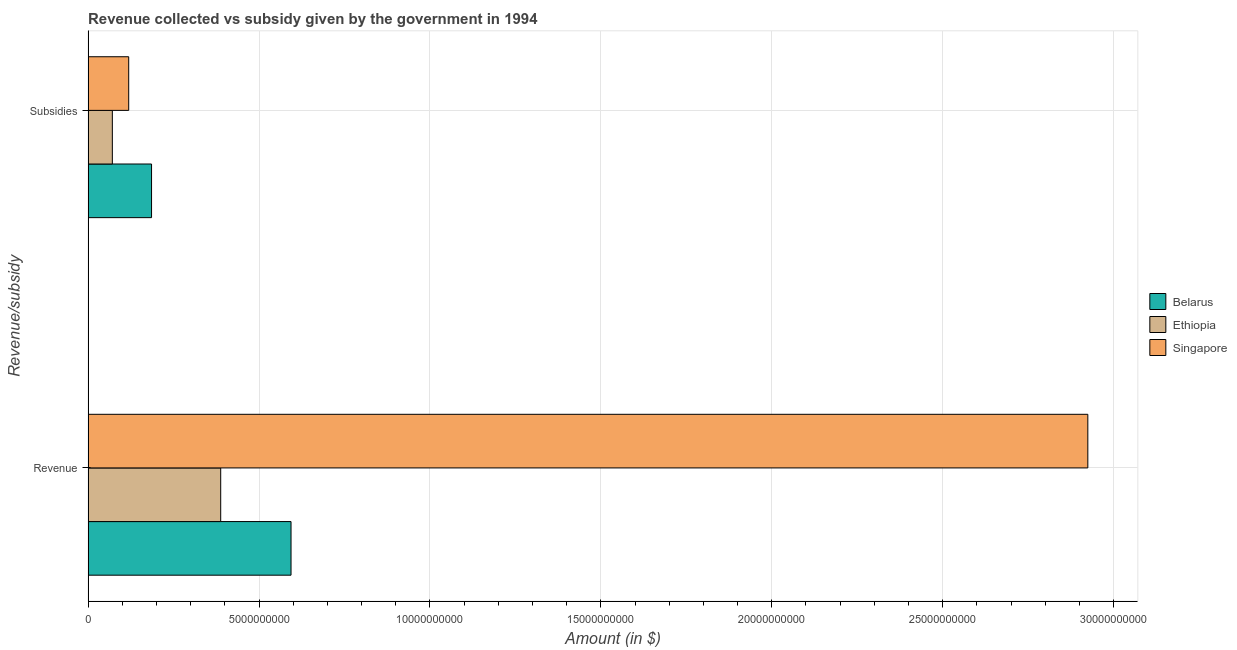Are the number of bars on each tick of the Y-axis equal?
Offer a terse response. Yes. How many bars are there on the 1st tick from the bottom?
Offer a very short reply. 3. What is the label of the 1st group of bars from the top?
Your response must be concise. Subsidies. What is the amount of subsidies given in Belarus?
Offer a terse response. 1.86e+09. Across all countries, what is the maximum amount of subsidies given?
Provide a succinct answer. 1.86e+09. Across all countries, what is the minimum amount of revenue collected?
Ensure brevity in your answer.  3.88e+09. In which country was the amount of revenue collected maximum?
Make the answer very short. Singapore. In which country was the amount of revenue collected minimum?
Your answer should be very brief. Ethiopia. What is the total amount of subsidies given in the graph?
Provide a short and direct response. 3.75e+09. What is the difference between the amount of subsidies given in Ethiopia and that in Belarus?
Provide a succinct answer. -1.15e+09. What is the difference between the amount of subsidies given in Ethiopia and the amount of revenue collected in Belarus?
Keep it short and to the point. -5.23e+09. What is the average amount of revenue collected per country?
Provide a succinct answer. 1.30e+1. What is the difference between the amount of subsidies given and amount of revenue collected in Singapore?
Keep it short and to the point. -2.81e+1. What is the ratio of the amount of revenue collected in Ethiopia to that in Belarus?
Ensure brevity in your answer.  0.65. Is the amount of subsidies given in Belarus less than that in Ethiopia?
Offer a very short reply. No. In how many countries, is the amount of revenue collected greater than the average amount of revenue collected taken over all countries?
Offer a terse response. 1. What does the 1st bar from the top in Subsidies represents?
Make the answer very short. Singapore. What does the 3rd bar from the bottom in Subsidies represents?
Your response must be concise. Singapore. How many bars are there?
Offer a very short reply. 6. How many countries are there in the graph?
Make the answer very short. 3. What is the difference between two consecutive major ticks on the X-axis?
Offer a very short reply. 5.00e+09. Are the values on the major ticks of X-axis written in scientific E-notation?
Make the answer very short. No. Does the graph contain any zero values?
Make the answer very short. No. What is the title of the graph?
Provide a short and direct response. Revenue collected vs subsidy given by the government in 1994. Does "Kazakhstan" appear as one of the legend labels in the graph?
Provide a succinct answer. No. What is the label or title of the X-axis?
Provide a short and direct response. Amount (in $). What is the label or title of the Y-axis?
Your answer should be compact. Revenue/subsidy. What is the Amount (in $) of Belarus in Revenue?
Ensure brevity in your answer.  5.94e+09. What is the Amount (in $) in Ethiopia in Revenue?
Your answer should be compact. 3.88e+09. What is the Amount (in $) of Singapore in Revenue?
Keep it short and to the point. 2.92e+1. What is the Amount (in $) in Belarus in Subsidies?
Keep it short and to the point. 1.86e+09. What is the Amount (in $) in Ethiopia in Subsidies?
Provide a short and direct response. 7.09e+08. What is the Amount (in $) in Singapore in Subsidies?
Your response must be concise. 1.19e+09. Across all Revenue/subsidy, what is the maximum Amount (in $) in Belarus?
Ensure brevity in your answer.  5.94e+09. Across all Revenue/subsidy, what is the maximum Amount (in $) of Ethiopia?
Your response must be concise. 3.88e+09. Across all Revenue/subsidy, what is the maximum Amount (in $) of Singapore?
Your answer should be very brief. 2.92e+1. Across all Revenue/subsidy, what is the minimum Amount (in $) in Belarus?
Give a very brief answer. 1.86e+09. Across all Revenue/subsidy, what is the minimum Amount (in $) of Ethiopia?
Your answer should be compact. 7.09e+08. Across all Revenue/subsidy, what is the minimum Amount (in $) in Singapore?
Provide a short and direct response. 1.19e+09. What is the total Amount (in $) of Belarus in the graph?
Make the answer very short. 7.79e+09. What is the total Amount (in $) in Ethiopia in the graph?
Provide a succinct answer. 4.59e+09. What is the total Amount (in $) in Singapore in the graph?
Offer a very short reply. 3.04e+1. What is the difference between the Amount (in $) of Belarus in Revenue and that in Subsidies?
Your response must be concise. 4.08e+09. What is the difference between the Amount (in $) in Ethiopia in Revenue and that in Subsidies?
Your answer should be compact. 3.17e+09. What is the difference between the Amount (in $) of Singapore in Revenue and that in Subsidies?
Provide a succinct answer. 2.81e+1. What is the difference between the Amount (in $) of Belarus in Revenue and the Amount (in $) of Ethiopia in Subsidies?
Ensure brevity in your answer.  5.23e+09. What is the difference between the Amount (in $) in Belarus in Revenue and the Amount (in $) in Singapore in Subsidies?
Your answer should be very brief. 4.75e+09. What is the difference between the Amount (in $) of Ethiopia in Revenue and the Amount (in $) of Singapore in Subsidies?
Offer a very short reply. 2.69e+09. What is the average Amount (in $) in Belarus per Revenue/subsidy?
Ensure brevity in your answer.  3.90e+09. What is the average Amount (in $) of Ethiopia per Revenue/subsidy?
Provide a short and direct response. 2.29e+09. What is the average Amount (in $) in Singapore per Revenue/subsidy?
Your answer should be very brief. 1.52e+1. What is the difference between the Amount (in $) of Belarus and Amount (in $) of Ethiopia in Revenue?
Give a very brief answer. 2.06e+09. What is the difference between the Amount (in $) in Belarus and Amount (in $) in Singapore in Revenue?
Provide a short and direct response. -2.33e+1. What is the difference between the Amount (in $) in Ethiopia and Amount (in $) in Singapore in Revenue?
Your response must be concise. -2.54e+1. What is the difference between the Amount (in $) in Belarus and Amount (in $) in Ethiopia in Subsidies?
Provide a short and direct response. 1.15e+09. What is the difference between the Amount (in $) in Belarus and Amount (in $) in Singapore in Subsidies?
Offer a very short reply. 6.68e+08. What is the difference between the Amount (in $) of Ethiopia and Amount (in $) of Singapore in Subsidies?
Your answer should be compact. -4.79e+08. What is the ratio of the Amount (in $) of Belarus in Revenue to that in Subsidies?
Offer a terse response. 3.2. What is the ratio of the Amount (in $) in Ethiopia in Revenue to that in Subsidies?
Your answer should be compact. 5.47. What is the ratio of the Amount (in $) in Singapore in Revenue to that in Subsidies?
Offer a very short reply. 24.62. What is the difference between the highest and the second highest Amount (in $) in Belarus?
Give a very brief answer. 4.08e+09. What is the difference between the highest and the second highest Amount (in $) in Ethiopia?
Your answer should be compact. 3.17e+09. What is the difference between the highest and the second highest Amount (in $) in Singapore?
Your response must be concise. 2.81e+1. What is the difference between the highest and the lowest Amount (in $) of Belarus?
Offer a terse response. 4.08e+09. What is the difference between the highest and the lowest Amount (in $) of Ethiopia?
Keep it short and to the point. 3.17e+09. What is the difference between the highest and the lowest Amount (in $) of Singapore?
Give a very brief answer. 2.81e+1. 